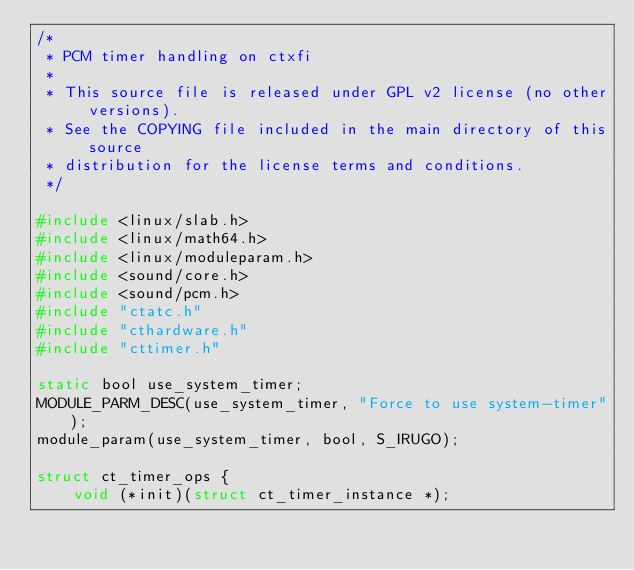Convert code to text. <code><loc_0><loc_0><loc_500><loc_500><_C_>/*
 * PCM timer handling on ctxfi
 *
 * This source file is released under GPL v2 license (no other versions).
 * See the COPYING file included in the main directory of this source
 * distribution for the license terms and conditions.
 */

#include <linux/slab.h>
#include <linux/math64.h>
#include <linux/moduleparam.h>
#include <sound/core.h>
#include <sound/pcm.h>
#include "ctatc.h"
#include "cthardware.h"
#include "cttimer.h"

static bool use_system_timer;
MODULE_PARM_DESC(use_system_timer, "Force to use system-timer");
module_param(use_system_timer, bool, S_IRUGO);

struct ct_timer_ops {
	void (*init)(struct ct_timer_instance *);</code> 